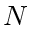<formula> <loc_0><loc_0><loc_500><loc_500>N</formula> 